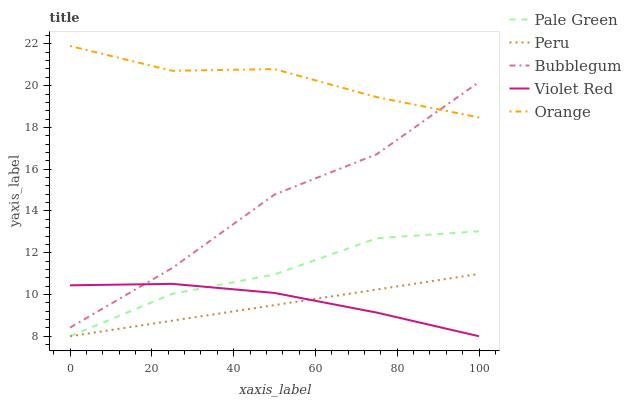Does Peru have the minimum area under the curve?
Answer yes or no. Yes. Does Orange have the maximum area under the curve?
Answer yes or no. Yes. Does Violet Red have the minimum area under the curve?
Answer yes or no. No. Does Violet Red have the maximum area under the curve?
Answer yes or no. No. Is Peru the smoothest?
Answer yes or no. Yes. Is Bubblegum the roughest?
Answer yes or no. Yes. Is Violet Red the smoothest?
Answer yes or no. No. Is Violet Red the roughest?
Answer yes or no. No. Does Violet Red have the lowest value?
Answer yes or no. Yes. Does Bubblegum have the lowest value?
Answer yes or no. No. Does Orange have the highest value?
Answer yes or no. Yes. Does Pale Green have the highest value?
Answer yes or no. No. Is Violet Red less than Orange?
Answer yes or no. Yes. Is Bubblegum greater than Peru?
Answer yes or no. Yes. Does Pale Green intersect Violet Red?
Answer yes or no. Yes. Is Pale Green less than Violet Red?
Answer yes or no. No. Is Pale Green greater than Violet Red?
Answer yes or no. No. Does Violet Red intersect Orange?
Answer yes or no. No. 